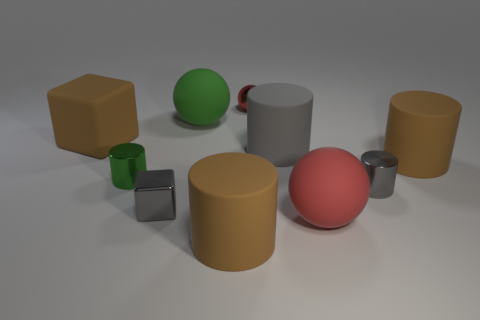Subtract all gray rubber cylinders. How many cylinders are left? 4 Subtract 1 cylinders. How many cylinders are left? 4 Subtract all green cylinders. How many cylinders are left? 4 Subtract all blue cylinders. Subtract all purple balls. How many cylinders are left? 5 Subtract all cubes. How many objects are left? 8 Subtract 0 brown balls. How many objects are left? 10 Subtract all big metal cylinders. Subtract all green things. How many objects are left? 8 Add 6 brown cylinders. How many brown cylinders are left? 8 Add 6 tiny gray metallic cylinders. How many tiny gray metallic cylinders exist? 7 